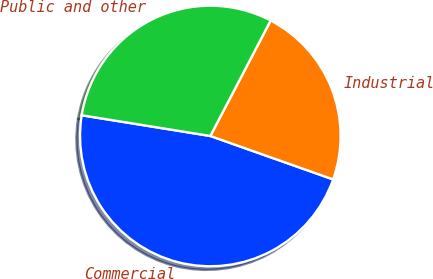Convert chart. <chart><loc_0><loc_0><loc_500><loc_500><pie_chart><fcel>Commercial<fcel>Industrial<fcel>Public and other<nl><fcel>47.13%<fcel>22.75%<fcel>30.12%<nl></chart> 